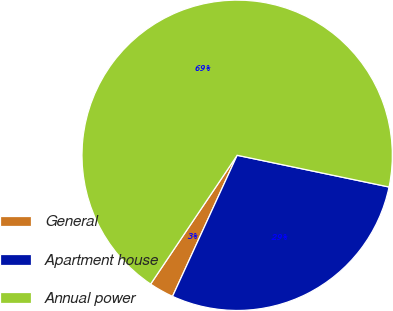<chart> <loc_0><loc_0><loc_500><loc_500><pie_chart><fcel>General<fcel>Apartment house<fcel>Annual power<nl><fcel>2.58%<fcel>28.56%<fcel>68.86%<nl></chart> 